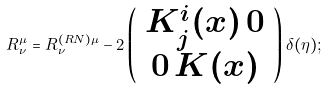Convert formula to latex. <formula><loc_0><loc_0><loc_500><loc_500>R ^ { \mu } _ { \nu } = R ^ { ( R N ) \mu } _ { \nu } - 2 \left ( \begin{array} { c } K ^ { i } _ { j } ( x ) \, 0 \\ 0 \, K ( x ) \end{array} \right ) \delta ( \eta ) ; \,</formula> 